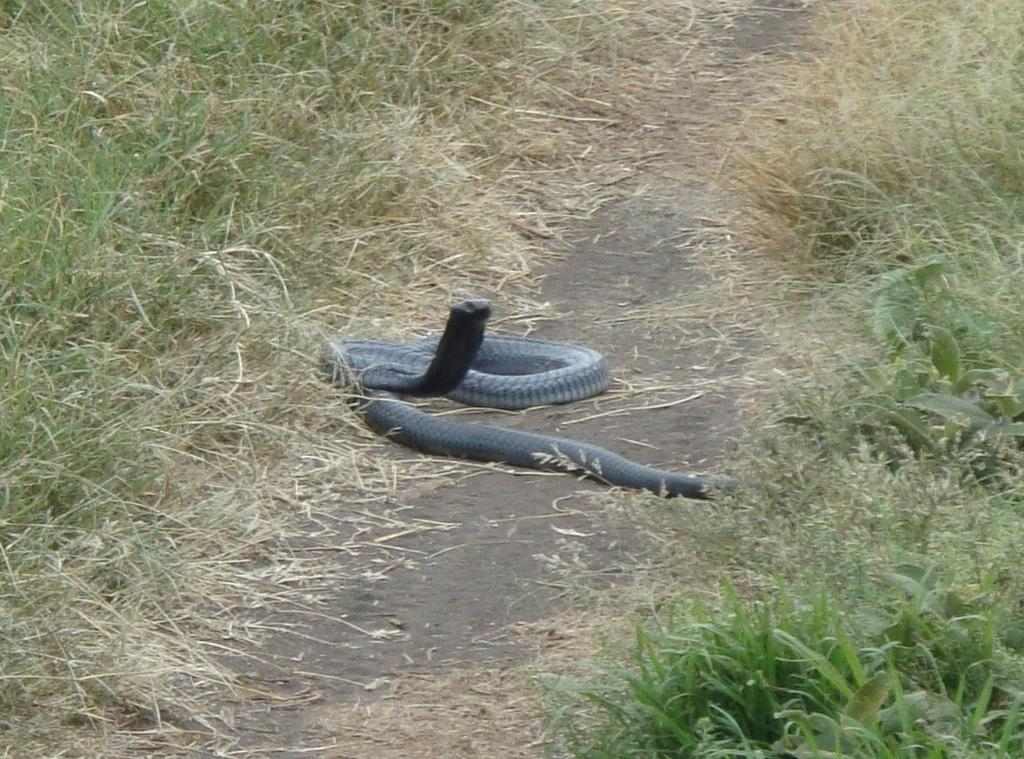What animal is present in the image? There is a snake in the image. Where is the snake located? The snake is on the ground in the image. What type of vegetation can be seen on the ground in the image? There is grass and plants on the ground in the image. What type of sign is the goose holding in the image? There is no goose or sign present in the image; it only features a snake on the ground. 